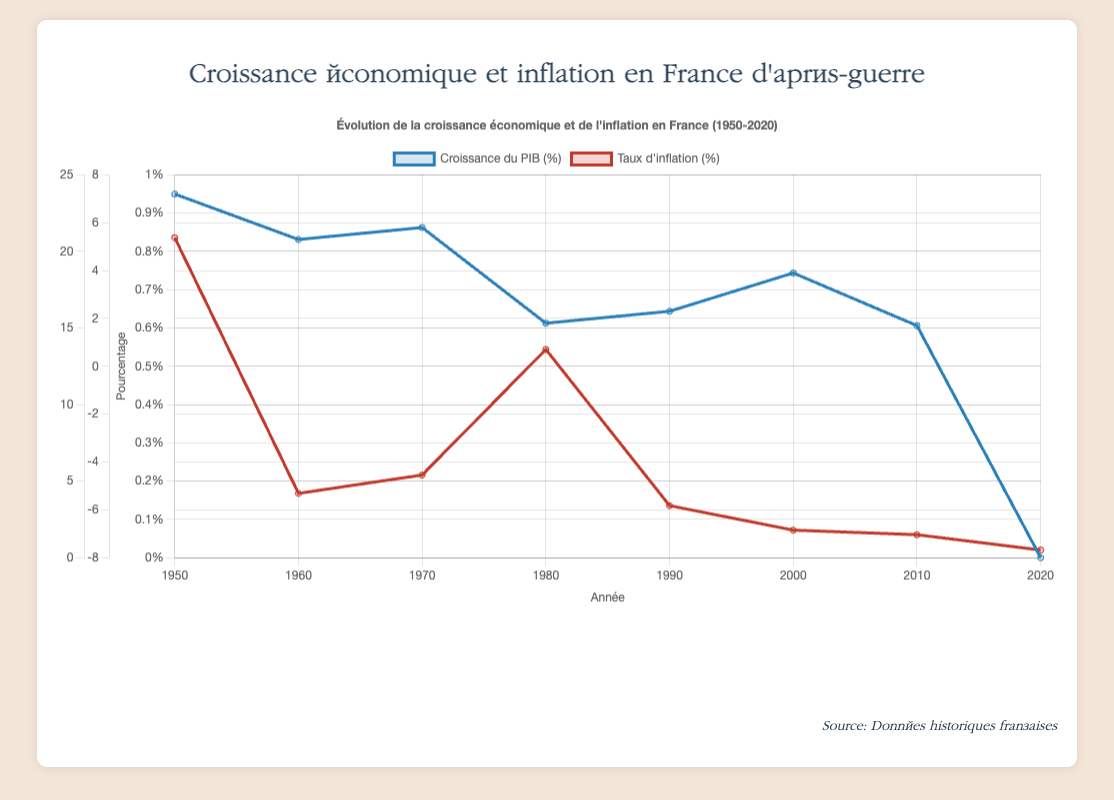What is the difference between GDP growth and inflation rate in 1950? To find the difference, subtract the inflation rate from the GDP growth for the year 1950. The GDP growth is 7.2% and the inflation rate is 20.9%. So, 7.2% - 20.9% = -13.7%.
Answer: -13.7% In which year was the GDP growth rate the highest? Look at the plot and identify the tallest line representing GDP growth rate. The highest point for GDP growth rate is in 1950 with a value of 7.2%.
Answer: 1950 How did inflation rate change from 1970 to 1980? Compare the inflation rates in 1970 and 1980. In 1970, it was 5.4%, and in 1980, it increased to 13.6%. Thus, the inflation rate increased from 5.4% to 13.6%.
Answer: Increased How many years had GDP growth lower than 2%? Scan the plot for years where the GDP growth is below 2%. The years meeting this criterion are 1980 and 2010.
Answer: 2 What was the inflation rate during the decade with the lowest GDP growth? Identify the decade with the lowest GDP growth, which is 2020 with -8.0% GDP growth. The inflation rate for the same decade is 0.5%.
Answer: 0.5% Which year had the lowest inflation rate? Look at the plot and find the minimum point for the inflation rate. The lowest inflation rate is in 2020 with a rate of 0.5%.
Answer: 2020 Compare the GDP growth rates of 1960 and 1980. Which one is higher? Examine the GDP growth rates for 1960 and 1980. In 1960, it is 5.3%, and in 1980, it is 1.8%. Hence, the GDP growth rate in 1960 is higher.
Answer: 1960 What is the average GDP growth rate from 1950 to 1980? Add the GDP growth rates for the years 1950, 1960, 1970, and 1980, then divide by the number of years. (7.2% + 5.3% + 5.8% + 1.8%) / 4 = 5.025%.
Answer: 5.025% Between which consecutive decades did the inflation rate decrease the most? Calculate the difference in inflation rates between each consecutive decade and find the largest decrease: (1950-1960 = 16.7%, 1960-1970 = -1.2%, 1970-1980 = 8.2%, 1980-1990 = -10.2%, 1990-2000 = -1.6%, 2000-2010 = -0.3%, 2010-2020 = -1.0%). The largest decrease is from 1980 to 1990 with -10.2%.
Answer: 1980 to 1990 